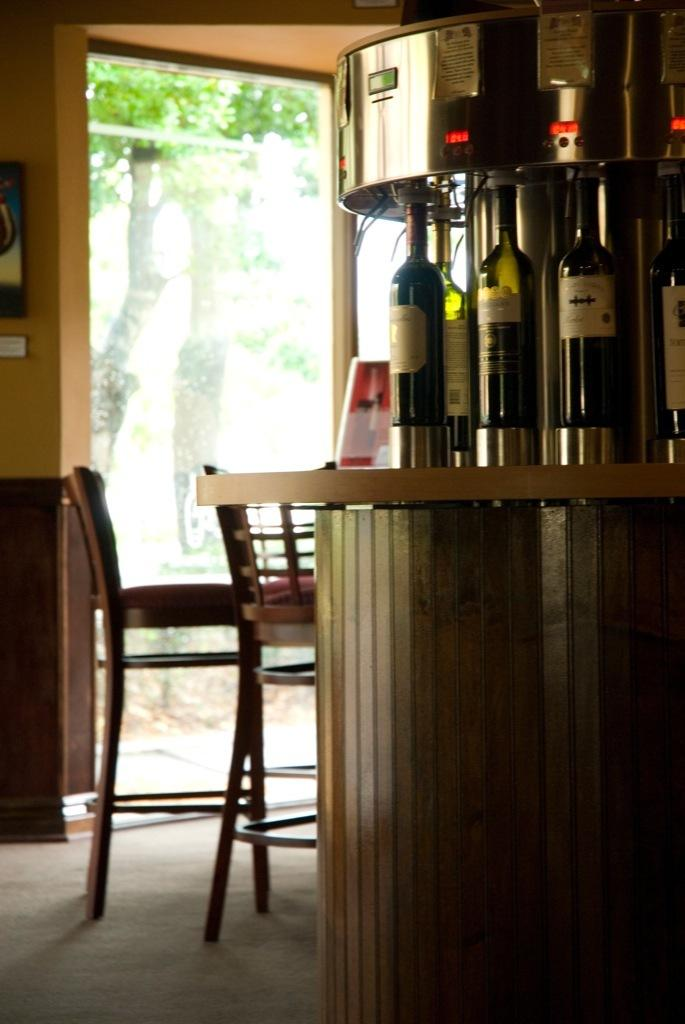What piece of furniture is present in the image? There is a table in the image. What is placed on the table? There are bottles on the table. What is connected to the bottles? A machine is attached to the bottles. How many chairs are in the image? There are two chairs in the image. What can be seen outside the image? There is a tree visible outside the image. What type of jellyfish is swimming in the bottle in the image? There are no jellyfish present in the image; it features bottles with a machine attached to them. What kind of jewel is hanging from the tree outside the image? There is no jewel hanging from the tree outside the image; only a tree is visible. 